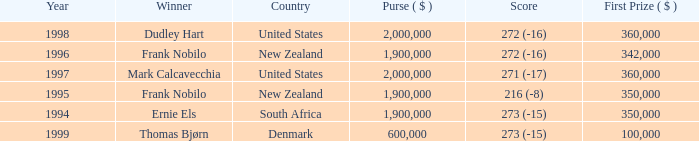What was the total purse in the years after 1996 with a score of 272 (-16) when frank nobilo won? None. 